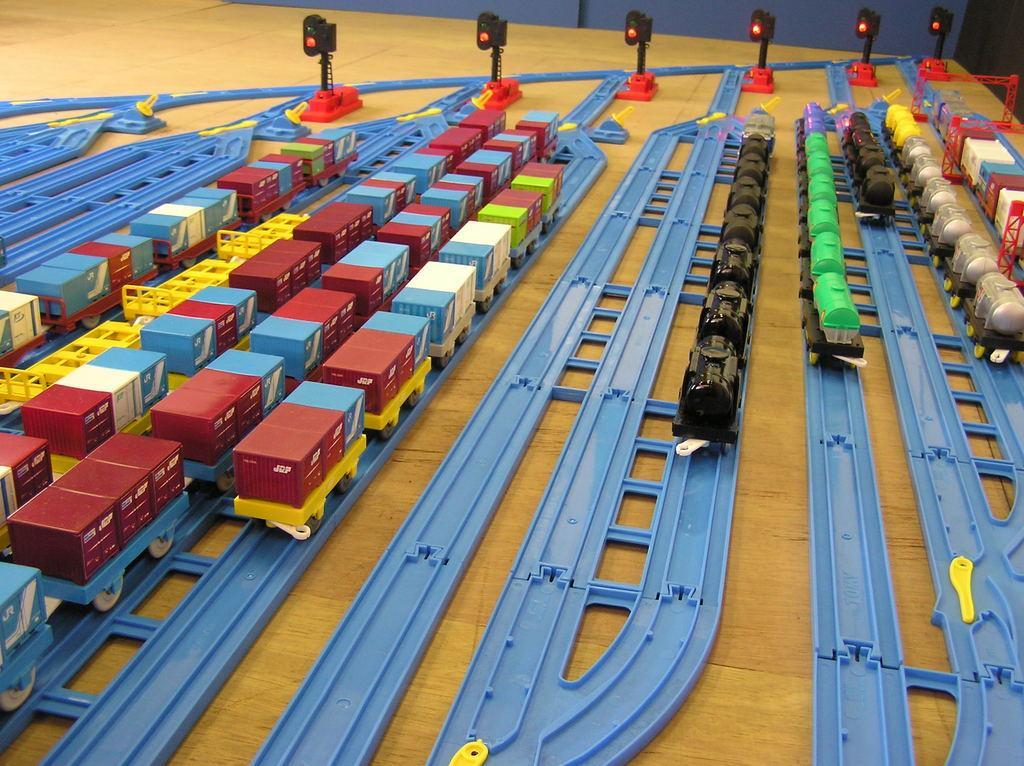In one or two sentences, can you explain what this image depicts? We can see toy trains on tracks and we can see traffic signals with poles. In the background it is blue. 